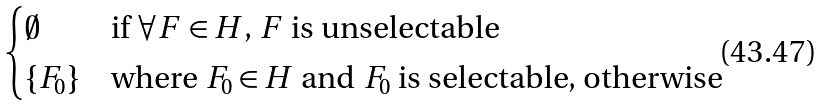Convert formula to latex. <formula><loc_0><loc_0><loc_500><loc_500>\begin{cases} \emptyset & \text {if $\forall F \in H$, $F$ is unselectable} \\ \{ F _ { 0 } \} & \text {where $F_{0} \in H$ and $F_{0}$ is selectable, otherwise} \end{cases}</formula> 